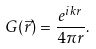<formula> <loc_0><loc_0><loc_500><loc_500>G ( \vec { r } ) = \frac { e ^ { i k r } } { 4 \pi r } .</formula> 